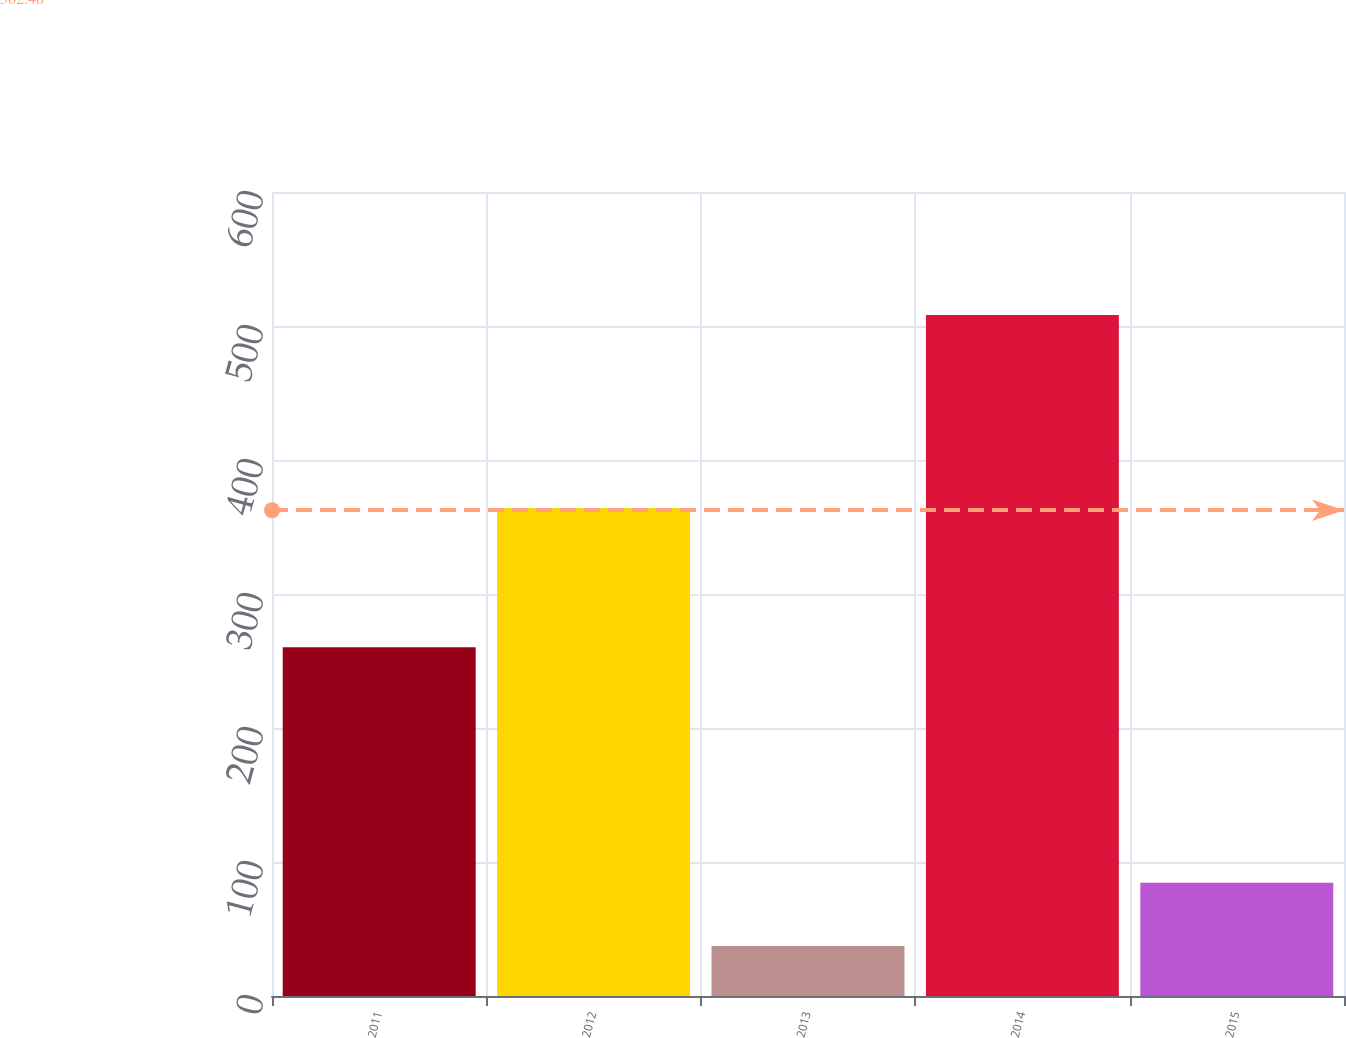Convert chart to OTSL. <chart><loc_0><loc_0><loc_500><loc_500><bar_chart><fcel>2011<fcel>2012<fcel>2013<fcel>2014<fcel>2015<nl><fcel>260.2<fcel>364.2<fcel>37.4<fcel>508.3<fcel>84.49<nl></chart> 